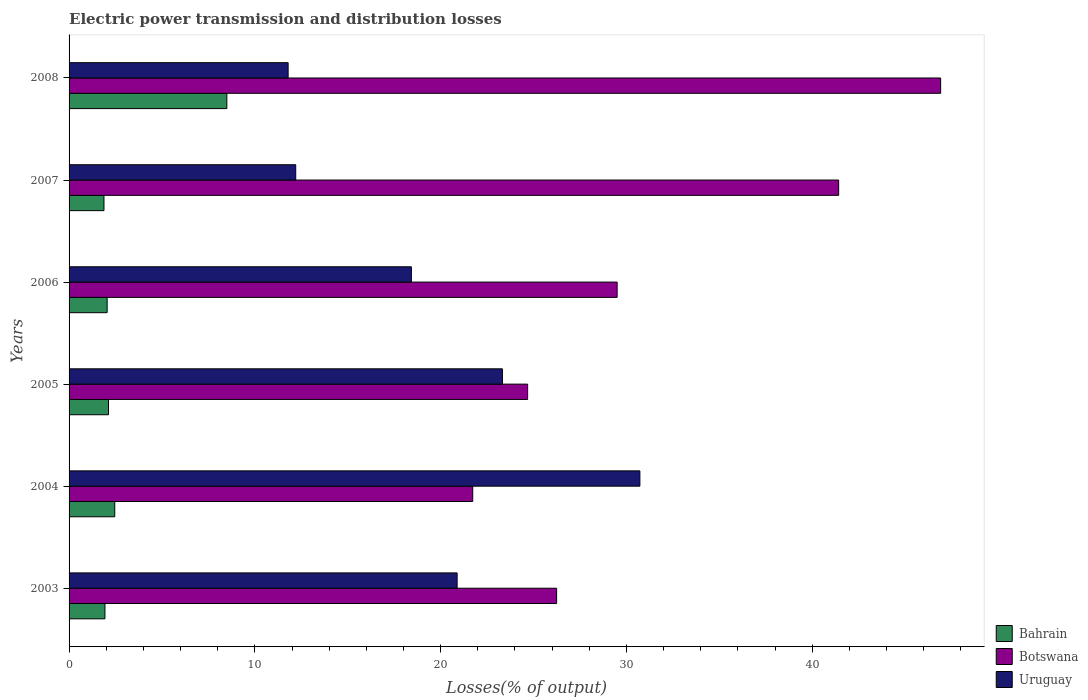How many different coloured bars are there?
Your answer should be very brief. 3. Are the number of bars per tick equal to the number of legend labels?
Ensure brevity in your answer.  Yes. How many bars are there on the 2nd tick from the bottom?
Make the answer very short. 3. What is the label of the 5th group of bars from the top?
Offer a very short reply. 2004. What is the electric power transmission and distribution losses in Bahrain in 2003?
Provide a succinct answer. 1.93. Across all years, what is the maximum electric power transmission and distribution losses in Botswana?
Provide a succinct answer. 46.92. Across all years, what is the minimum electric power transmission and distribution losses in Uruguay?
Offer a very short reply. 11.79. In which year was the electric power transmission and distribution losses in Botswana maximum?
Provide a short and direct response. 2008. What is the total electric power transmission and distribution losses in Bahrain in the graph?
Offer a very short reply. 18.93. What is the difference between the electric power transmission and distribution losses in Botswana in 2005 and that in 2007?
Your answer should be compact. -16.74. What is the difference between the electric power transmission and distribution losses in Bahrain in 2006 and the electric power transmission and distribution losses in Botswana in 2008?
Give a very brief answer. -44.87. What is the average electric power transmission and distribution losses in Botswana per year?
Provide a short and direct response. 31.75. In the year 2006, what is the difference between the electric power transmission and distribution losses in Uruguay and electric power transmission and distribution losses in Bahrain?
Ensure brevity in your answer.  16.38. What is the ratio of the electric power transmission and distribution losses in Bahrain in 2003 to that in 2004?
Provide a succinct answer. 0.79. Is the electric power transmission and distribution losses in Botswana in 2004 less than that in 2007?
Give a very brief answer. Yes. What is the difference between the highest and the second highest electric power transmission and distribution losses in Botswana?
Give a very brief answer. 5.49. What is the difference between the highest and the lowest electric power transmission and distribution losses in Botswana?
Offer a very short reply. 25.19. In how many years, is the electric power transmission and distribution losses in Botswana greater than the average electric power transmission and distribution losses in Botswana taken over all years?
Offer a very short reply. 2. Is the sum of the electric power transmission and distribution losses in Bahrain in 2004 and 2006 greater than the maximum electric power transmission and distribution losses in Uruguay across all years?
Offer a very short reply. No. What does the 1st bar from the top in 2004 represents?
Offer a very short reply. Uruguay. What does the 3rd bar from the bottom in 2006 represents?
Offer a terse response. Uruguay. How many years are there in the graph?
Give a very brief answer. 6. Are the values on the major ticks of X-axis written in scientific E-notation?
Provide a succinct answer. No. Does the graph contain any zero values?
Offer a very short reply. No. Does the graph contain grids?
Provide a succinct answer. No. Where does the legend appear in the graph?
Your response must be concise. Bottom right. How are the legend labels stacked?
Keep it short and to the point. Vertical. What is the title of the graph?
Offer a terse response. Electric power transmission and distribution losses. What is the label or title of the X-axis?
Offer a terse response. Losses(% of output). What is the label or title of the Y-axis?
Make the answer very short. Years. What is the Losses(% of output) in Bahrain in 2003?
Offer a very short reply. 1.93. What is the Losses(% of output) of Botswana in 2003?
Give a very brief answer. 26.24. What is the Losses(% of output) in Uruguay in 2003?
Provide a short and direct response. 20.89. What is the Losses(% of output) in Bahrain in 2004?
Offer a very short reply. 2.46. What is the Losses(% of output) of Botswana in 2004?
Offer a very short reply. 21.73. What is the Losses(% of output) in Uruguay in 2004?
Offer a very short reply. 30.73. What is the Losses(% of output) of Bahrain in 2005?
Your answer should be very brief. 2.12. What is the Losses(% of output) in Botswana in 2005?
Your answer should be very brief. 24.68. What is the Losses(% of output) in Uruguay in 2005?
Keep it short and to the point. 23.33. What is the Losses(% of output) of Bahrain in 2006?
Your response must be concise. 2.05. What is the Losses(% of output) of Botswana in 2006?
Provide a succinct answer. 29.5. What is the Losses(% of output) of Uruguay in 2006?
Offer a terse response. 18.43. What is the Losses(% of output) in Bahrain in 2007?
Provide a short and direct response. 1.88. What is the Losses(% of output) in Botswana in 2007?
Provide a succinct answer. 41.43. What is the Losses(% of output) of Uruguay in 2007?
Your answer should be compact. 12.2. What is the Losses(% of output) in Bahrain in 2008?
Ensure brevity in your answer.  8.49. What is the Losses(% of output) in Botswana in 2008?
Keep it short and to the point. 46.92. What is the Losses(% of output) of Uruguay in 2008?
Your answer should be compact. 11.79. Across all years, what is the maximum Losses(% of output) in Bahrain?
Keep it short and to the point. 8.49. Across all years, what is the maximum Losses(% of output) of Botswana?
Ensure brevity in your answer.  46.92. Across all years, what is the maximum Losses(% of output) of Uruguay?
Provide a short and direct response. 30.73. Across all years, what is the minimum Losses(% of output) in Bahrain?
Offer a very short reply. 1.88. Across all years, what is the minimum Losses(% of output) in Botswana?
Give a very brief answer. 21.73. Across all years, what is the minimum Losses(% of output) of Uruguay?
Give a very brief answer. 11.79. What is the total Losses(% of output) of Bahrain in the graph?
Give a very brief answer. 18.93. What is the total Losses(% of output) of Botswana in the graph?
Offer a terse response. 190.5. What is the total Losses(% of output) in Uruguay in the graph?
Your answer should be very brief. 117.36. What is the difference between the Losses(% of output) of Bahrain in 2003 and that in 2004?
Provide a short and direct response. -0.53. What is the difference between the Losses(% of output) of Botswana in 2003 and that in 2004?
Provide a succinct answer. 4.51. What is the difference between the Losses(% of output) in Uruguay in 2003 and that in 2004?
Give a very brief answer. -9.84. What is the difference between the Losses(% of output) of Bahrain in 2003 and that in 2005?
Offer a very short reply. -0.19. What is the difference between the Losses(% of output) of Botswana in 2003 and that in 2005?
Provide a succinct answer. 1.56. What is the difference between the Losses(% of output) of Uruguay in 2003 and that in 2005?
Keep it short and to the point. -2.44. What is the difference between the Losses(% of output) of Bahrain in 2003 and that in 2006?
Offer a terse response. -0.12. What is the difference between the Losses(% of output) of Botswana in 2003 and that in 2006?
Your answer should be very brief. -3.26. What is the difference between the Losses(% of output) in Uruguay in 2003 and that in 2006?
Provide a short and direct response. 2.46. What is the difference between the Losses(% of output) in Bahrain in 2003 and that in 2007?
Provide a short and direct response. 0.05. What is the difference between the Losses(% of output) in Botswana in 2003 and that in 2007?
Your answer should be very brief. -15.18. What is the difference between the Losses(% of output) of Uruguay in 2003 and that in 2007?
Keep it short and to the point. 8.69. What is the difference between the Losses(% of output) in Bahrain in 2003 and that in 2008?
Your response must be concise. -6.56. What is the difference between the Losses(% of output) in Botswana in 2003 and that in 2008?
Keep it short and to the point. -20.67. What is the difference between the Losses(% of output) of Uruguay in 2003 and that in 2008?
Your answer should be very brief. 9.1. What is the difference between the Losses(% of output) of Bahrain in 2004 and that in 2005?
Ensure brevity in your answer.  0.34. What is the difference between the Losses(% of output) in Botswana in 2004 and that in 2005?
Provide a succinct answer. -2.95. What is the difference between the Losses(% of output) of Uruguay in 2004 and that in 2005?
Your response must be concise. 7.4. What is the difference between the Losses(% of output) in Bahrain in 2004 and that in 2006?
Provide a succinct answer. 0.41. What is the difference between the Losses(% of output) in Botswana in 2004 and that in 2006?
Your response must be concise. -7.77. What is the difference between the Losses(% of output) in Uruguay in 2004 and that in 2006?
Your answer should be compact. 12.3. What is the difference between the Losses(% of output) in Bahrain in 2004 and that in 2007?
Provide a short and direct response. 0.58. What is the difference between the Losses(% of output) of Botswana in 2004 and that in 2007?
Provide a succinct answer. -19.7. What is the difference between the Losses(% of output) in Uruguay in 2004 and that in 2007?
Your answer should be very brief. 18.53. What is the difference between the Losses(% of output) in Bahrain in 2004 and that in 2008?
Your answer should be compact. -6.03. What is the difference between the Losses(% of output) in Botswana in 2004 and that in 2008?
Offer a very short reply. -25.19. What is the difference between the Losses(% of output) of Uruguay in 2004 and that in 2008?
Give a very brief answer. 18.93. What is the difference between the Losses(% of output) of Bahrain in 2005 and that in 2006?
Make the answer very short. 0.07. What is the difference between the Losses(% of output) in Botswana in 2005 and that in 2006?
Offer a terse response. -4.82. What is the difference between the Losses(% of output) of Uruguay in 2005 and that in 2006?
Your answer should be compact. 4.9. What is the difference between the Losses(% of output) in Bahrain in 2005 and that in 2007?
Your answer should be compact. 0.24. What is the difference between the Losses(% of output) of Botswana in 2005 and that in 2007?
Provide a short and direct response. -16.74. What is the difference between the Losses(% of output) of Uruguay in 2005 and that in 2007?
Keep it short and to the point. 11.13. What is the difference between the Losses(% of output) in Bahrain in 2005 and that in 2008?
Provide a short and direct response. -6.37. What is the difference between the Losses(% of output) in Botswana in 2005 and that in 2008?
Keep it short and to the point. -22.23. What is the difference between the Losses(% of output) of Uruguay in 2005 and that in 2008?
Provide a succinct answer. 11.54. What is the difference between the Losses(% of output) in Bahrain in 2006 and that in 2007?
Give a very brief answer. 0.17. What is the difference between the Losses(% of output) in Botswana in 2006 and that in 2007?
Your answer should be compact. -11.92. What is the difference between the Losses(% of output) of Uruguay in 2006 and that in 2007?
Provide a short and direct response. 6.23. What is the difference between the Losses(% of output) in Bahrain in 2006 and that in 2008?
Offer a terse response. -6.44. What is the difference between the Losses(% of output) in Botswana in 2006 and that in 2008?
Provide a succinct answer. -17.41. What is the difference between the Losses(% of output) of Uruguay in 2006 and that in 2008?
Provide a succinct answer. 6.63. What is the difference between the Losses(% of output) in Bahrain in 2007 and that in 2008?
Offer a very short reply. -6.61. What is the difference between the Losses(% of output) of Botswana in 2007 and that in 2008?
Provide a succinct answer. -5.49. What is the difference between the Losses(% of output) in Uruguay in 2007 and that in 2008?
Make the answer very short. 0.41. What is the difference between the Losses(% of output) in Bahrain in 2003 and the Losses(% of output) in Botswana in 2004?
Provide a succinct answer. -19.8. What is the difference between the Losses(% of output) of Bahrain in 2003 and the Losses(% of output) of Uruguay in 2004?
Your answer should be compact. -28.8. What is the difference between the Losses(% of output) of Botswana in 2003 and the Losses(% of output) of Uruguay in 2004?
Provide a short and direct response. -4.48. What is the difference between the Losses(% of output) in Bahrain in 2003 and the Losses(% of output) in Botswana in 2005?
Make the answer very short. -22.75. What is the difference between the Losses(% of output) in Bahrain in 2003 and the Losses(% of output) in Uruguay in 2005?
Make the answer very short. -21.4. What is the difference between the Losses(% of output) of Botswana in 2003 and the Losses(% of output) of Uruguay in 2005?
Offer a terse response. 2.92. What is the difference between the Losses(% of output) of Bahrain in 2003 and the Losses(% of output) of Botswana in 2006?
Your answer should be compact. -27.57. What is the difference between the Losses(% of output) of Bahrain in 2003 and the Losses(% of output) of Uruguay in 2006?
Make the answer very short. -16.5. What is the difference between the Losses(% of output) in Botswana in 2003 and the Losses(% of output) in Uruguay in 2006?
Offer a terse response. 7.82. What is the difference between the Losses(% of output) in Bahrain in 2003 and the Losses(% of output) in Botswana in 2007?
Your response must be concise. -39.49. What is the difference between the Losses(% of output) in Bahrain in 2003 and the Losses(% of output) in Uruguay in 2007?
Give a very brief answer. -10.27. What is the difference between the Losses(% of output) of Botswana in 2003 and the Losses(% of output) of Uruguay in 2007?
Offer a very short reply. 14.04. What is the difference between the Losses(% of output) in Bahrain in 2003 and the Losses(% of output) in Botswana in 2008?
Keep it short and to the point. -44.98. What is the difference between the Losses(% of output) of Bahrain in 2003 and the Losses(% of output) of Uruguay in 2008?
Your answer should be compact. -9.86. What is the difference between the Losses(% of output) in Botswana in 2003 and the Losses(% of output) in Uruguay in 2008?
Make the answer very short. 14.45. What is the difference between the Losses(% of output) in Bahrain in 2004 and the Losses(% of output) in Botswana in 2005?
Give a very brief answer. -22.22. What is the difference between the Losses(% of output) in Bahrain in 2004 and the Losses(% of output) in Uruguay in 2005?
Your answer should be compact. -20.87. What is the difference between the Losses(% of output) of Botswana in 2004 and the Losses(% of output) of Uruguay in 2005?
Offer a terse response. -1.6. What is the difference between the Losses(% of output) of Bahrain in 2004 and the Losses(% of output) of Botswana in 2006?
Give a very brief answer. -27.04. What is the difference between the Losses(% of output) in Bahrain in 2004 and the Losses(% of output) in Uruguay in 2006?
Give a very brief answer. -15.97. What is the difference between the Losses(% of output) of Botswana in 2004 and the Losses(% of output) of Uruguay in 2006?
Ensure brevity in your answer.  3.3. What is the difference between the Losses(% of output) of Bahrain in 2004 and the Losses(% of output) of Botswana in 2007?
Provide a succinct answer. -38.97. What is the difference between the Losses(% of output) in Bahrain in 2004 and the Losses(% of output) in Uruguay in 2007?
Your answer should be very brief. -9.74. What is the difference between the Losses(% of output) in Botswana in 2004 and the Losses(% of output) in Uruguay in 2007?
Ensure brevity in your answer.  9.53. What is the difference between the Losses(% of output) in Bahrain in 2004 and the Losses(% of output) in Botswana in 2008?
Your answer should be compact. -44.46. What is the difference between the Losses(% of output) in Bahrain in 2004 and the Losses(% of output) in Uruguay in 2008?
Provide a short and direct response. -9.33. What is the difference between the Losses(% of output) of Botswana in 2004 and the Losses(% of output) of Uruguay in 2008?
Your response must be concise. 9.94. What is the difference between the Losses(% of output) in Bahrain in 2005 and the Losses(% of output) in Botswana in 2006?
Your answer should be compact. -27.38. What is the difference between the Losses(% of output) of Bahrain in 2005 and the Losses(% of output) of Uruguay in 2006?
Your answer should be very brief. -16.3. What is the difference between the Losses(% of output) of Botswana in 2005 and the Losses(% of output) of Uruguay in 2006?
Keep it short and to the point. 6.26. What is the difference between the Losses(% of output) in Bahrain in 2005 and the Losses(% of output) in Botswana in 2007?
Keep it short and to the point. -39.3. What is the difference between the Losses(% of output) of Bahrain in 2005 and the Losses(% of output) of Uruguay in 2007?
Your answer should be very brief. -10.08. What is the difference between the Losses(% of output) in Botswana in 2005 and the Losses(% of output) in Uruguay in 2007?
Offer a terse response. 12.48. What is the difference between the Losses(% of output) of Bahrain in 2005 and the Losses(% of output) of Botswana in 2008?
Provide a succinct answer. -44.79. What is the difference between the Losses(% of output) in Bahrain in 2005 and the Losses(% of output) in Uruguay in 2008?
Keep it short and to the point. -9.67. What is the difference between the Losses(% of output) of Botswana in 2005 and the Losses(% of output) of Uruguay in 2008?
Provide a succinct answer. 12.89. What is the difference between the Losses(% of output) of Bahrain in 2006 and the Losses(% of output) of Botswana in 2007?
Keep it short and to the point. -39.38. What is the difference between the Losses(% of output) of Bahrain in 2006 and the Losses(% of output) of Uruguay in 2007?
Provide a succinct answer. -10.15. What is the difference between the Losses(% of output) in Botswana in 2006 and the Losses(% of output) in Uruguay in 2007?
Your response must be concise. 17.3. What is the difference between the Losses(% of output) in Bahrain in 2006 and the Losses(% of output) in Botswana in 2008?
Offer a very short reply. -44.87. What is the difference between the Losses(% of output) in Bahrain in 2006 and the Losses(% of output) in Uruguay in 2008?
Give a very brief answer. -9.74. What is the difference between the Losses(% of output) in Botswana in 2006 and the Losses(% of output) in Uruguay in 2008?
Provide a short and direct response. 17.71. What is the difference between the Losses(% of output) of Bahrain in 2007 and the Losses(% of output) of Botswana in 2008?
Provide a short and direct response. -45.04. What is the difference between the Losses(% of output) of Bahrain in 2007 and the Losses(% of output) of Uruguay in 2008?
Offer a terse response. -9.91. What is the difference between the Losses(% of output) of Botswana in 2007 and the Losses(% of output) of Uruguay in 2008?
Give a very brief answer. 29.63. What is the average Losses(% of output) of Bahrain per year?
Make the answer very short. 3.16. What is the average Losses(% of output) of Botswana per year?
Provide a succinct answer. 31.75. What is the average Losses(% of output) in Uruguay per year?
Your response must be concise. 19.56. In the year 2003, what is the difference between the Losses(% of output) of Bahrain and Losses(% of output) of Botswana?
Keep it short and to the point. -24.31. In the year 2003, what is the difference between the Losses(% of output) in Bahrain and Losses(% of output) in Uruguay?
Ensure brevity in your answer.  -18.96. In the year 2003, what is the difference between the Losses(% of output) in Botswana and Losses(% of output) in Uruguay?
Your response must be concise. 5.35. In the year 2004, what is the difference between the Losses(% of output) in Bahrain and Losses(% of output) in Botswana?
Your answer should be compact. -19.27. In the year 2004, what is the difference between the Losses(% of output) of Bahrain and Losses(% of output) of Uruguay?
Provide a short and direct response. -28.27. In the year 2004, what is the difference between the Losses(% of output) in Botswana and Losses(% of output) in Uruguay?
Make the answer very short. -9. In the year 2005, what is the difference between the Losses(% of output) of Bahrain and Losses(% of output) of Botswana?
Your response must be concise. -22.56. In the year 2005, what is the difference between the Losses(% of output) in Bahrain and Losses(% of output) in Uruguay?
Ensure brevity in your answer.  -21.21. In the year 2005, what is the difference between the Losses(% of output) in Botswana and Losses(% of output) in Uruguay?
Make the answer very short. 1.36. In the year 2006, what is the difference between the Losses(% of output) of Bahrain and Losses(% of output) of Botswana?
Provide a succinct answer. -27.45. In the year 2006, what is the difference between the Losses(% of output) in Bahrain and Losses(% of output) in Uruguay?
Give a very brief answer. -16.38. In the year 2006, what is the difference between the Losses(% of output) of Botswana and Losses(% of output) of Uruguay?
Ensure brevity in your answer.  11.08. In the year 2007, what is the difference between the Losses(% of output) in Bahrain and Losses(% of output) in Botswana?
Offer a terse response. -39.55. In the year 2007, what is the difference between the Losses(% of output) of Bahrain and Losses(% of output) of Uruguay?
Ensure brevity in your answer.  -10.32. In the year 2007, what is the difference between the Losses(% of output) in Botswana and Losses(% of output) in Uruguay?
Ensure brevity in your answer.  29.22. In the year 2008, what is the difference between the Losses(% of output) of Bahrain and Losses(% of output) of Botswana?
Ensure brevity in your answer.  -38.42. In the year 2008, what is the difference between the Losses(% of output) of Bahrain and Losses(% of output) of Uruguay?
Provide a succinct answer. -3.3. In the year 2008, what is the difference between the Losses(% of output) in Botswana and Losses(% of output) in Uruguay?
Make the answer very short. 35.12. What is the ratio of the Losses(% of output) in Bahrain in 2003 to that in 2004?
Keep it short and to the point. 0.79. What is the ratio of the Losses(% of output) in Botswana in 2003 to that in 2004?
Offer a terse response. 1.21. What is the ratio of the Losses(% of output) of Uruguay in 2003 to that in 2004?
Offer a terse response. 0.68. What is the ratio of the Losses(% of output) of Bahrain in 2003 to that in 2005?
Make the answer very short. 0.91. What is the ratio of the Losses(% of output) of Botswana in 2003 to that in 2005?
Offer a terse response. 1.06. What is the ratio of the Losses(% of output) in Uruguay in 2003 to that in 2005?
Give a very brief answer. 0.9. What is the ratio of the Losses(% of output) of Bahrain in 2003 to that in 2006?
Give a very brief answer. 0.94. What is the ratio of the Losses(% of output) of Botswana in 2003 to that in 2006?
Offer a very short reply. 0.89. What is the ratio of the Losses(% of output) of Uruguay in 2003 to that in 2006?
Provide a short and direct response. 1.13. What is the ratio of the Losses(% of output) of Bahrain in 2003 to that in 2007?
Give a very brief answer. 1.03. What is the ratio of the Losses(% of output) in Botswana in 2003 to that in 2007?
Your answer should be very brief. 0.63. What is the ratio of the Losses(% of output) of Uruguay in 2003 to that in 2007?
Your response must be concise. 1.71. What is the ratio of the Losses(% of output) in Bahrain in 2003 to that in 2008?
Make the answer very short. 0.23. What is the ratio of the Losses(% of output) of Botswana in 2003 to that in 2008?
Offer a terse response. 0.56. What is the ratio of the Losses(% of output) in Uruguay in 2003 to that in 2008?
Your answer should be very brief. 1.77. What is the ratio of the Losses(% of output) in Bahrain in 2004 to that in 2005?
Your answer should be very brief. 1.16. What is the ratio of the Losses(% of output) of Botswana in 2004 to that in 2005?
Offer a terse response. 0.88. What is the ratio of the Losses(% of output) of Uruguay in 2004 to that in 2005?
Keep it short and to the point. 1.32. What is the ratio of the Losses(% of output) of Bahrain in 2004 to that in 2006?
Provide a succinct answer. 1.2. What is the ratio of the Losses(% of output) of Botswana in 2004 to that in 2006?
Give a very brief answer. 0.74. What is the ratio of the Losses(% of output) in Uruguay in 2004 to that in 2006?
Your answer should be very brief. 1.67. What is the ratio of the Losses(% of output) in Bahrain in 2004 to that in 2007?
Your answer should be compact. 1.31. What is the ratio of the Losses(% of output) of Botswana in 2004 to that in 2007?
Provide a succinct answer. 0.52. What is the ratio of the Losses(% of output) in Uruguay in 2004 to that in 2007?
Offer a terse response. 2.52. What is the ratio of the Losses(% of output) in Bahrain in 2004 to that in 2008?
Your response must be concise. 0.29. What is the ratio of the Losses(% of output) in Botswana in 2004 to that in 2008?
Your answer should be very brief. 0.46. What is the ratio of the Losses(% of output) of Uruguay in 2004 to that in 2008?
Your response must be concise. 2.61. What is the ratio of the Losses(% of output) in Bahrain in 2005 to that in 2006?
Ensure brevity in your answer.  1.04. What is the ratio of the Losses(% of output) of Botswana in 2005 to that in 2006?
Provide a succinct answer. 0.84. What is the ratio of the Losses(% of output) in Uruguay in 2005 to that in 2006?
Offer a very short reply. 1.27. What is the ratio of the Losses(% of output) of Bahrain in 2005 to that in 2007?
Your response must be concise. 1.13. What is the ratio of the Losses(% of output) of Botswana in 2005 to that in 2007?
Your answer should be compact. 0.6. What is the ratio of the Losses(% of output) of Uruguay in 2005 to that in 2007?
Your answer should be very brief. 1.91. What is the ratio of the Losses(% of output) in Bahrain in 2005 to that in 2008?
Your response must be concise. 0.25. What is the ratio of the Losses(% of output) of Botswana in 2005 to that in 2008?
Provide a succinct answer. 0.53. What is the ratio of the Losses(% of output) in Uruguay in 2005 to that in 2008?
Provide a short and direct response. 1.98. What is the ratio of the Losses(% of output) of Bahrain in 2006 to that in 2007?
Offer a terse response. 1.09. What is the ratio of the Losses(% of output) in Botswana in 2006 to that in 2007?
Give a very brief answer. 0.71. What is the ratio of the Losses(% of output) in Uruguay in 2006 to that in 2007?
Your response must be concise. 1.51. What is the ratio of the Losses(% of output) in Bahrain in 2006 to that in 2008?
Give a very brief answer. 0.24. What is the ratio of the Losses(% of output) in Botswana in 2006 to that in 2008?
Make the answer very short. 0.63. What is the ratio of the Losses(% of output) in Uruguay in 2006 to that in 2008?
Your response must be concise. 1.56. What is the ratio of the Losses(% of output) of Bahrain in 2007 to that in 2008?
Your answer should be compact. 0.22. What is the ratio of the Losses(% of output) of Botswana in 2007 to that in 2008?
Provide a short and direct response. 0.88. What is the ratio of the Losses(% of output) of Uruguay in 2007 to that in 2008?
Offer a terse response. 1.03. What is the difference between the highest and the second highest Losses(% of output) in Bahrain?
Offer a very short reply. 6.03. What is the difference between the highest and the second highest Losses(% of output) in Botswana?
Make the answer very short. 5.49. What is the difference between the highest and the second highest Losses(% of output) of Uruguay?
Your response must be concise. 7.4. What is the difference between the highest and the lowest Losses(% of output) of Bahrain?
Give a very brief answer. 6.61. What is the difference between the highest and the lowest Losses(% of output) in Botswana?
Keep it short and to the point. 25.19. What is the difference between the highest and the lowest Losses(% of output) of Uruguay?
Your answer should be compact. 18.93. 